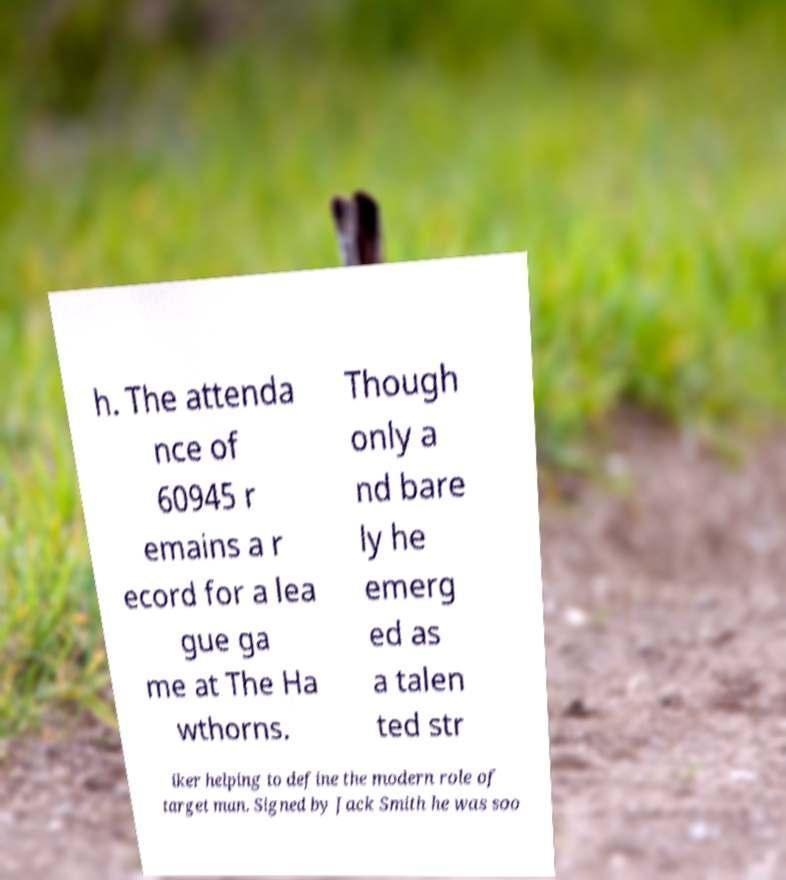Could you extract and type out the text from this image? h. The attenda nce of 60945 r emains a r ecord for a lea gue ga me at The Ha wthorns. Though only a nd bare ly he emerg ed as a talen ted str iker helping to define the modern role of target man. Signed by Jack Smith he was soo 